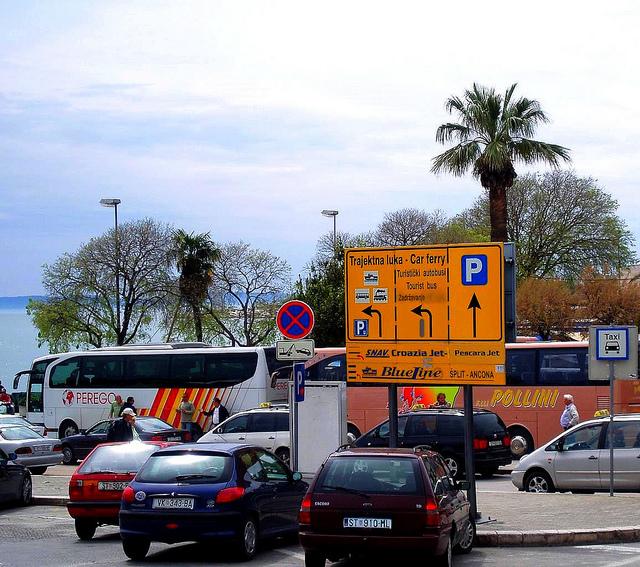What route is on the blue street sign?
Concise answer only. Parking. What does the first bus say?
Keep it brief. Perego. Where do you go to park?
Write a very short answer. Straight ahead. How buses are there?
Concise answer only. 2. 